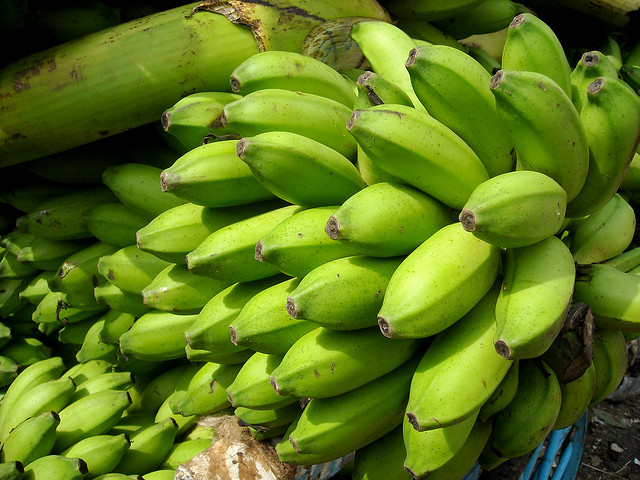<image>What brand of banana is pictured? It is uncertain what brand of banana is pictured. It might be 'dole' or 'chiquita'. What brand of banana is pictured? I am not sure what brand of banana is pictured. It can be 'dole' or 'chiquita'. 